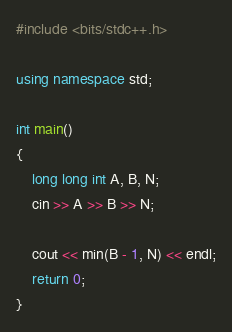<code> <loc_0><loc_0><loc_500><loc_500><_C++_>#include <bits/stdc++.h>

using namespace std;

int main()
{
    long long int A, B, N;
    cin >> A >> B >> N;

    cout << min(B - 1, N) << endl;
    return 0;
}</code> 